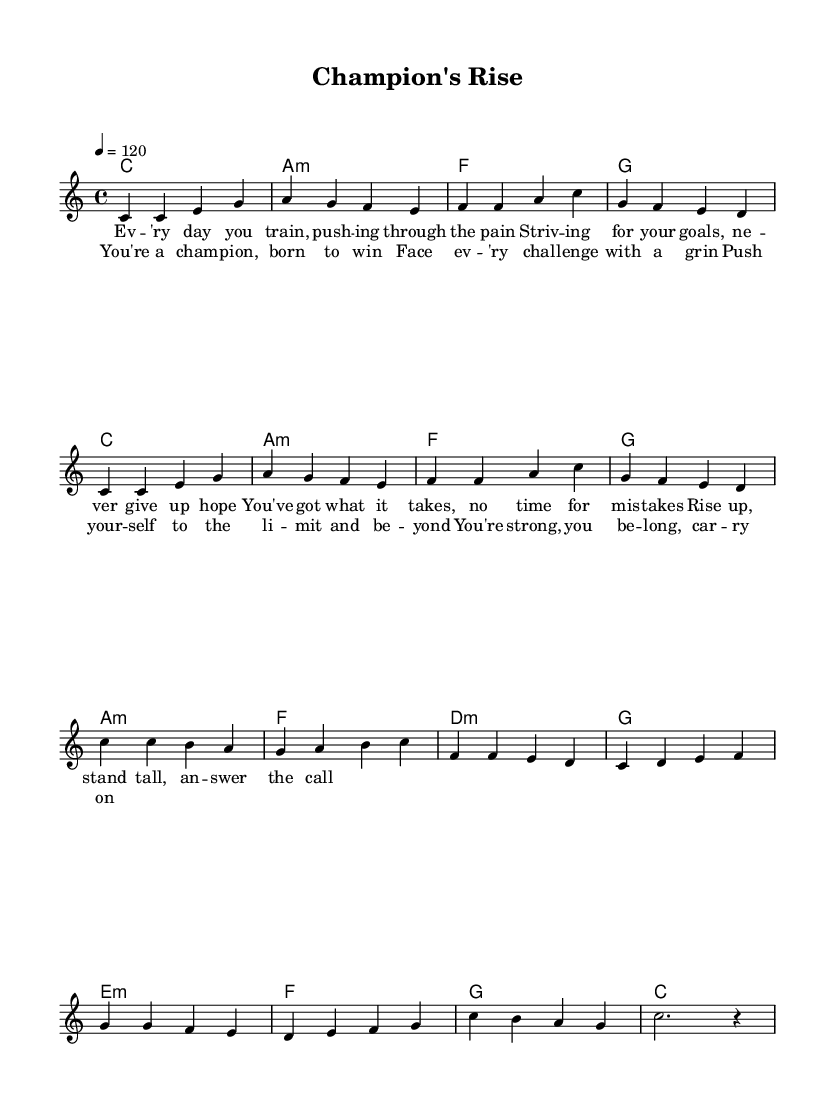What is the key signature of this music? The key signature is C major, indicated by the absence of sharps or flats on the staff.
Answer: C major What is the time signature of this music? The time signature is 4/4, illustrated by the two numbers at the beginning of the piece, with four beats in each measure.
Answer: 4/4 What is the tempo marking for this music? The tempo marking is 120 beats per minute, specified by "4 = 120," indicating the speed at which the piece should be played.
Answer: 120 How many measures are in the chorus section? The chorus consists of 4 measures, which can be counted by identifying the grouping of musical notes and rests within that section.
Answer: 4 What is the repeated chord progression in the core of the music? The repeated chord progression is C, A minor, F, G, identified in the chord mode of the score which shows how the chords are structured throughout the piece.
Answer: C, A minor, F, G What lyrical theme does the title "Champion's Rise" suggest? The title suggests themes of perseverance, overcoming challenges, and striving for victory, which aligns with the motivational content of the lyrics focused on athletic achievement.
Answer: Perseverance 